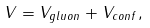Convert formula to latex. <formula><loc_0><loc_0><loc_500><loc_500>V = V _ { g l u o n } + V _ { c o n f } ,</formula> 